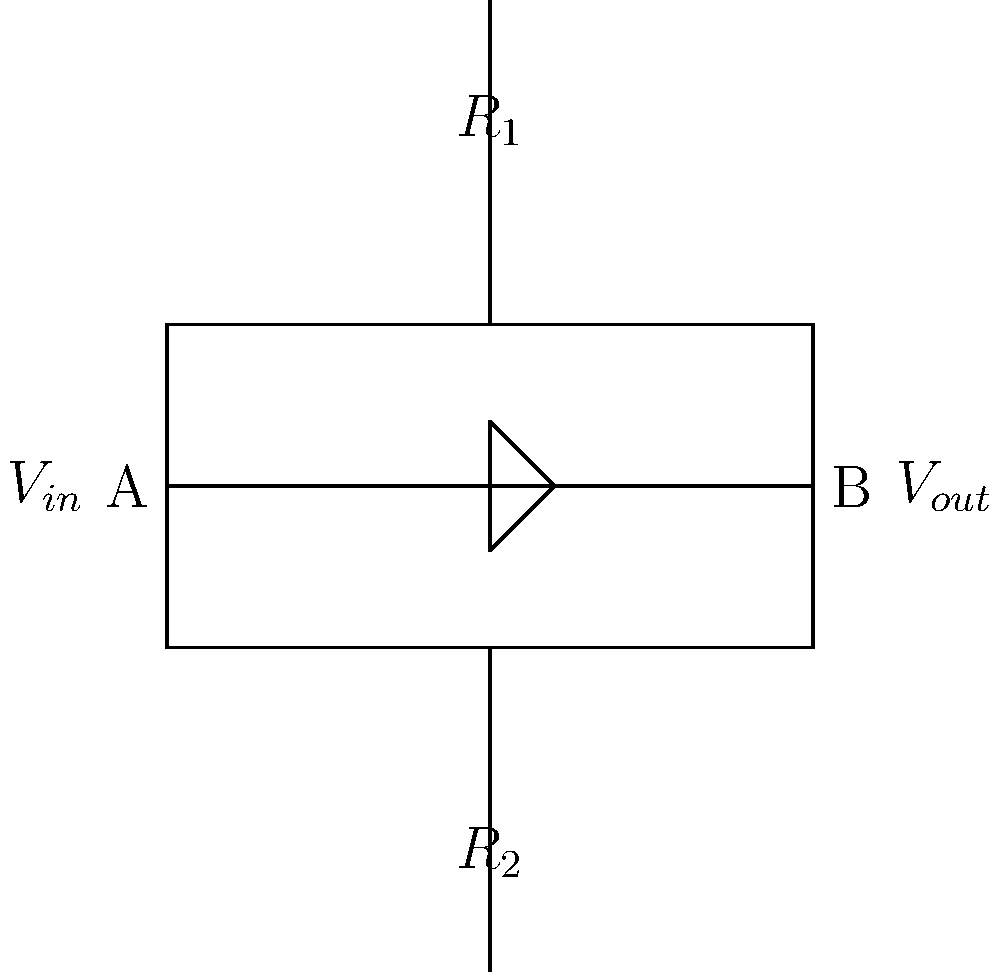In the simple amplifier circuit shown above, which is commonly used in audio equipment for live performances, what is the primary function of resistor $R_2$? To understand the function of $R_2$ in this simple amplifier circuit, let's break down the components and their roles:

1. The circuit shown is a common-emitter amplifier configuration using a single transistor.

2. $R_1$ is the collector resistor, which helps set the operating point of the transistor and contributes to the voltage gain of the amplifier.

3. The transistor amplifies the input signal applied at $V_{in}$.

4. $R_2$, connected between the emitter of the transistor and ground, is called the emitter resistor.

5. The primary function of $R_2$ is to provide negative feedback, which stabilizes the operating point of the transistor against variations in temperature and transistor parameters.

6. This negative feedback also helps reduce distortion in the amplified signal, which is crucial for maintaining audio quality in live performances.

7. Additionally, $R_2$ affects the input impedance and gain of the amplifier. A larger $R_2$ value increases input impedance but decreases gain, while a smaller $R_2$ value does the opposite.

8. In audio applications, the value of $R_2$ is often chosen to balance between stable operation, desired gain, and acceptable distortion levels.

Therefore, the primary function of $R_2$ in this circuit is to provide negative feedback for stabilization and distortion reduction.
Answer: Provide negative feedback for stabilization and distortion reduction 